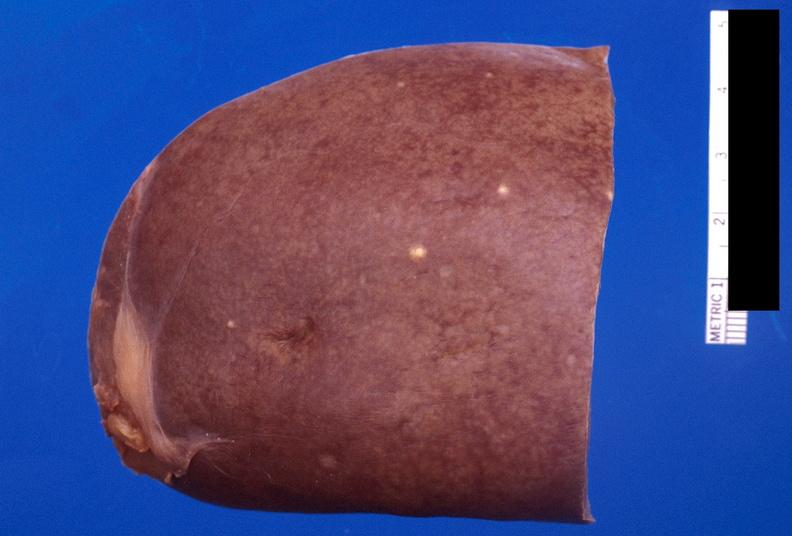what is present?
Answer the question using a single word or phrase. Hematologic 